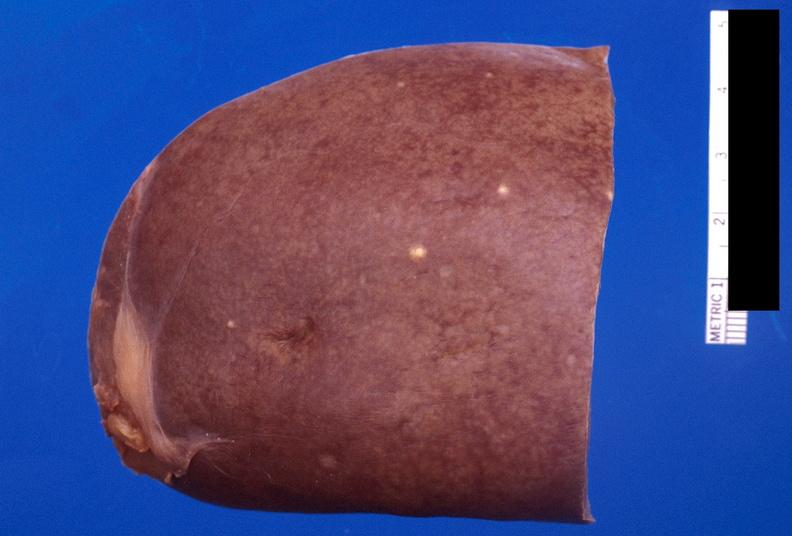what is present?
Answer the question using a single word or phrase. Hematologic 